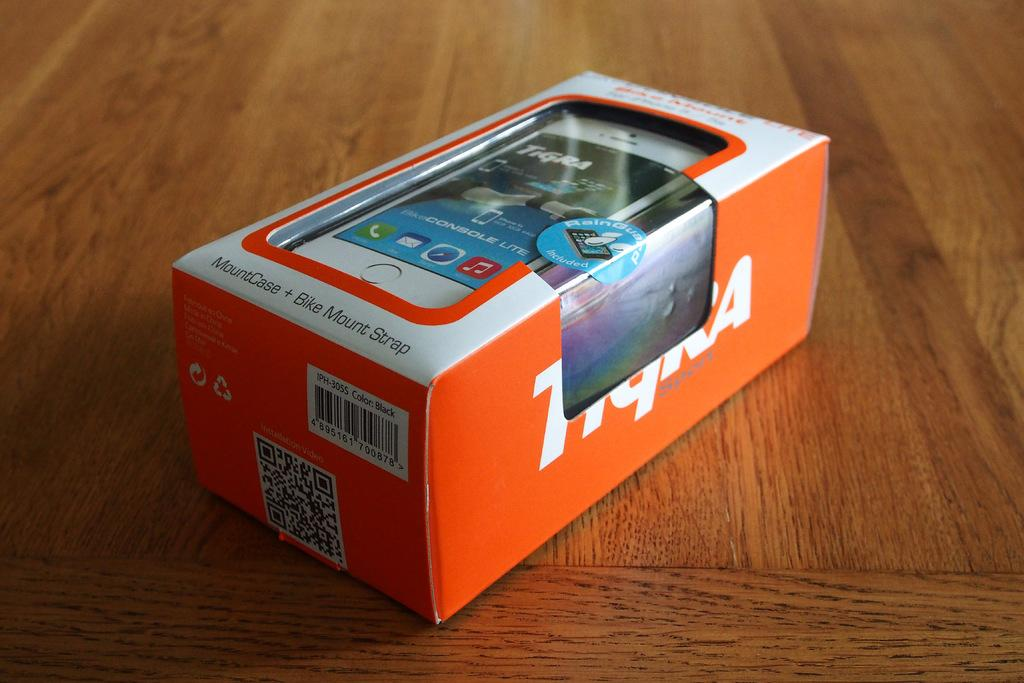<image>
Provide a brief description of the given image. A case with a bike mount is in an orange and white box. 